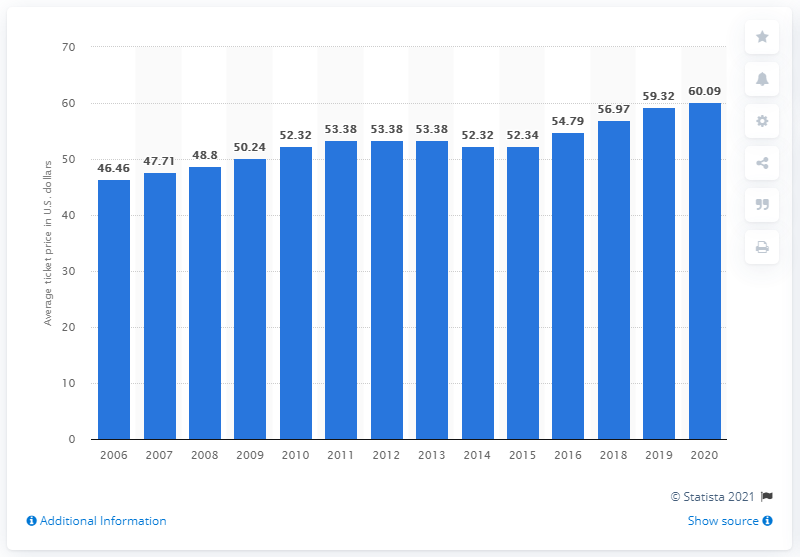Highlight a few significant elements in this photo. The average ticket price for a Red Sox game in 2020 was $60.09. 